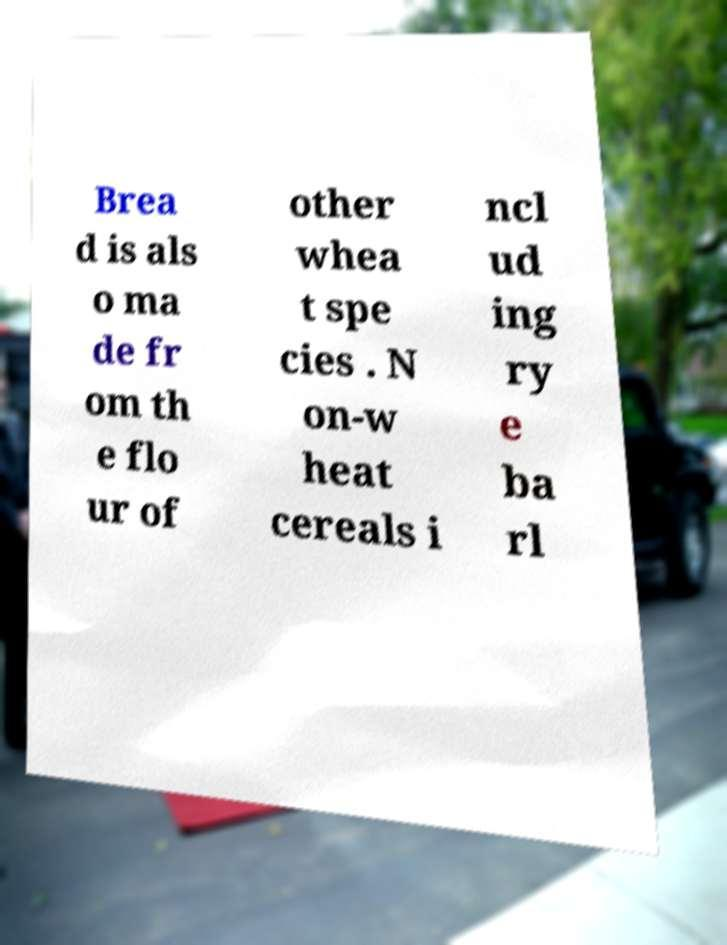Please identify and transcribe the text found in this image. Brea d is als o ma de fr om th e flo ur of other whea t spe cies . N on-w heat cereals i ncl ud ing ry e ba rl 